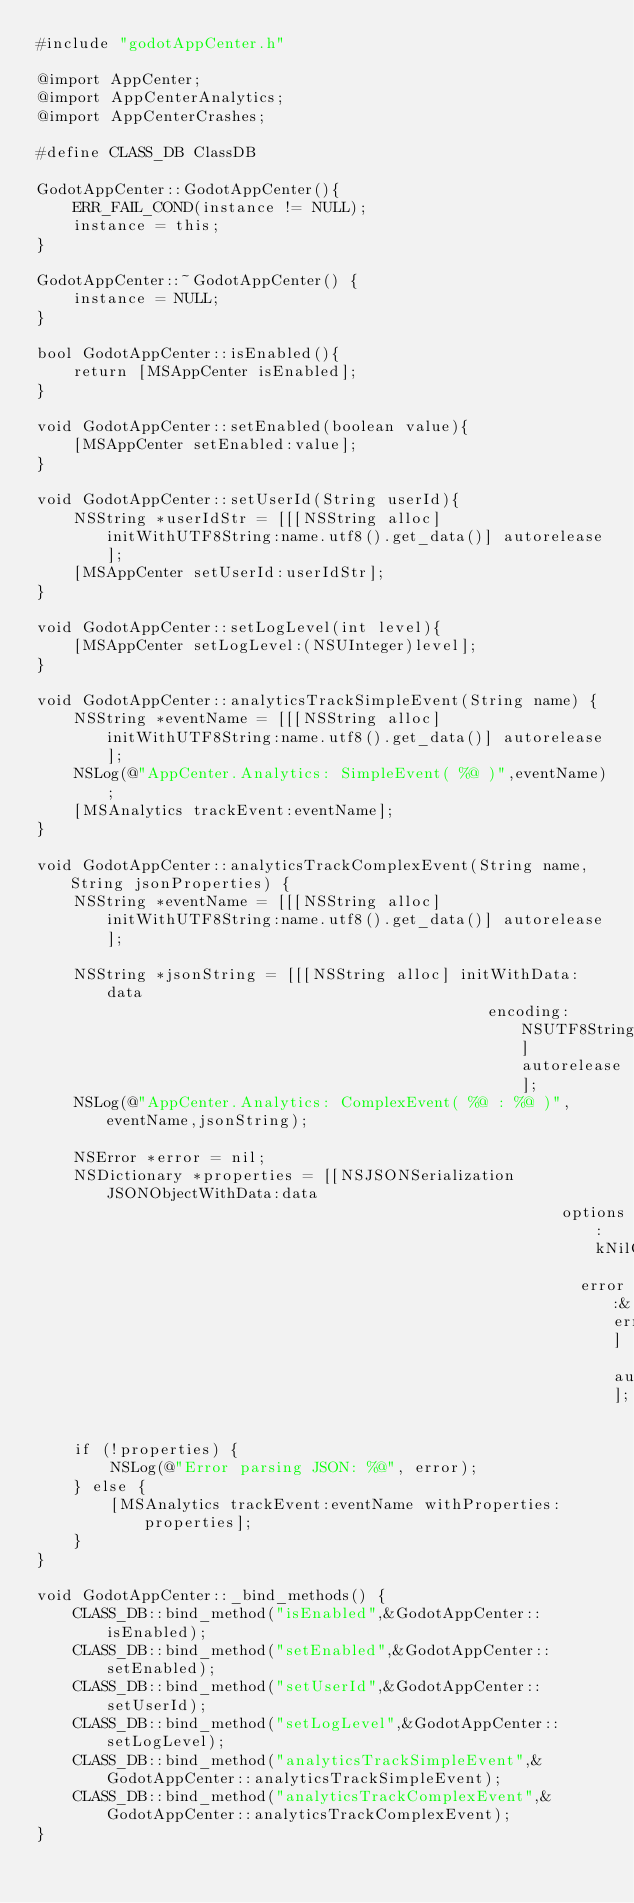<code> <loc_0><loc_0><loc_500><loc_500><_ObjectiveC_>#include "godotAppCenter.h"

@import AppCenter;
@import AppCenterAnalytics;
@import AppCenterCrashes;

#define CLASS_DB ClassDB

GodotAppCenter::GodotAppCenter(){
    ERR_FAIL_COND(instance != NULL);
    instance = this;
}

GodotAppCenter::~GodotAppCenter() {
    instance = NULL;
}

bool GodotAppCenter::isEnabled(){
    return [MSAppCenter isEnabled];
}

void GodotAppCenter::setEnabled(boolean value){
    [MSAppCenter setEnabled:value];
}

void GodotAppCenter::setUserId(String userId){
    NSString *userIdStr = [[[NSString alloc] initWithUTF8String:name.utf8().get_data()] autorelease];
    [MSAppCenter setUserId:userIdStr];
}

void GodotAppCenter::setLogLevel(int level){
    [MSAppCenter setLogLevel:(NSUInteger)level];
}

void GodotAppCenter::analyticsTrackSimpleEvent(String name) {
    NSString *eventName = [[[NSString alloc] initWithUTF8String:name.utf8().get_data()] autorelease];
    NSLog(@"AppCenter.Analytics: SimpleEvent( %@ )",eventName);
    [MSAnalytics trackEvent:eventName];
}

void GodotAppCenter::analyticsTrackComplexEvent(String name, String jsonProperties) {
    NSString *eventName = [[[NSString alloc] initWithUTF8String:name.utf8().get_data()] autorelease];

    NSString *jsonString = [[[NSString alloc] initWithData:data
                                                 encoding:NSUTF8StringEncoding] autorelease];
    NSLog(@"AppCenter.Analytics: ComplexEvent( %@ : %@ )",eventName,jsonString);

    NSError *error = nil;
    NSDictionary *properties = [[NSJSONSerialization JSONObjectWithData:data
                                                         options:kNilOptions 
                                                           error:&error] autorelease];

    if (!properties) {
        NSLog(@"Error parsing JSON: %@", error);
    } else {
        [MSAnalytics trackEvent:eventName withProperties:properties];
    }
}

void GodotAppCenter::_bind_methods() {
    CLASS_DB::bind_method("isEnabled",&GodotAppCenter::isEnabled);
    CLASS_DB::bind_method("setEnabled",&GodotAppCenter::setEnabled);
    CLASS_DB::bind_method("setUserId",&GodotAppCenter::setUserId);
    CLASS_DB::bind_method("setLogLevel",&GodotAppCenter::setLogLevel);
    CLASS_DB::bind_method("analyticsTrackSimpleEvent",&GodotAppCenter::analyticsTrackSimpleEvent);
    CLASS_DB::bind_method("analyticsTrackComplexEvent",&GodotAppCenter::analyticsTrackComplexEvent);
}</code> 